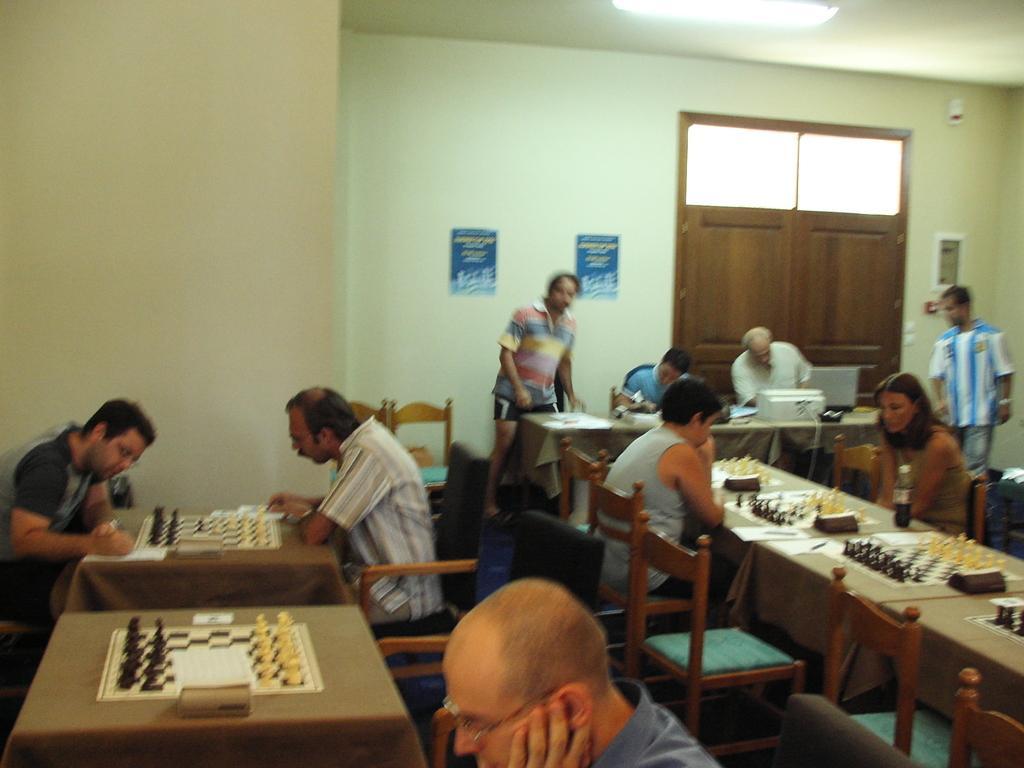In one or two sentences, can you explain what this image depicts? Here, a group of people in hall. Each pair is sitting in opposite direction and playing chess. There are two men at left side and two men on to the right side of the image. Four men at the back and a man in the front middle of the image. 